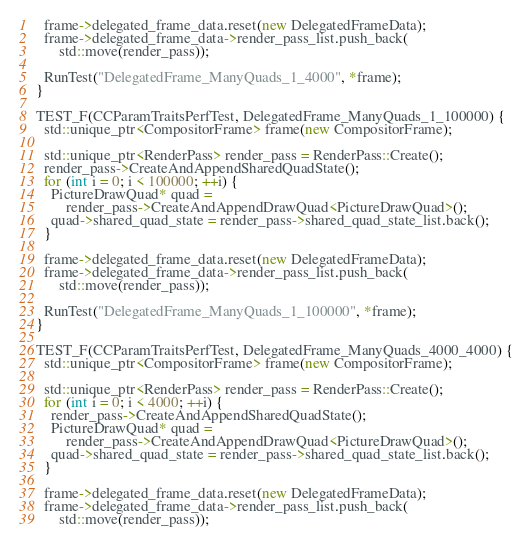Convert code to text. <code><loc_0><loc_0><loc_500><loc_500><_C++_>
  frame->delegated_frame_data.reset(new DelegatedFrameData);
  frame->delegated_frame_data->render_pass_list.push_back(
      std::move(render_pass));

  RunTest("DelegatedFrame_ManyQuads_1_4000", *frame);
}

TEST_F(CCParamTraitsPerfTest, DelegatedFrame_ManyQuads_1_100000) {
  std::unique_ptr<CompositorFrame> frame(new CompositorFrame);

  std::unique_ptr<RenderPass> render_pass = RenderPass::Create();
  render_pass->CreateAndAppendSharedQuadState();
  for (int i = 0; i < 100000; ++i) {
    PictureDrawQuad* quad =
        render_pass->CreateAndAppendDrawQuad<PictureDrawQuad>();
    quad->shared_quad_state = render_pass->shared_quad_state_list.back();
  }

  frame->delegated_frame_data.reset(new DelegatedFrameData);
  frame->delegated_frame_data->render_pass_list.push_back(
      std::move(render_pass));

  RunTest("DelegatedFrame_ManyQuads_1_100000", *frame);
}

TEST_F(CCParamTraitsPerfTest, DelegatedFrame_ManyQuads_4000_4000) {
  std::unique_ptr<CompositorFrame> frame(new CompositorFrame);

  std::unique_ptr<RenderPass> render_pass = RenderPass::Create();
  for (int i = 0; i < 4000; ++i) {
    render_pass->CreateAndAppendSharedQuadState();
    PictureDrawQuad* quad =
        render_pass->CreateAndAppendDrawQuad<PictureDrawQuad>();
    quad->shared_quad_state = render_pass->shared_quad_state_list.back();
  }

  frame->delegated_frame_data.reset(new DelegatedFrameData);
  frame->delegated_frame_data->render_pass_list.push_back(
      std::move(render_pass));
</code> 